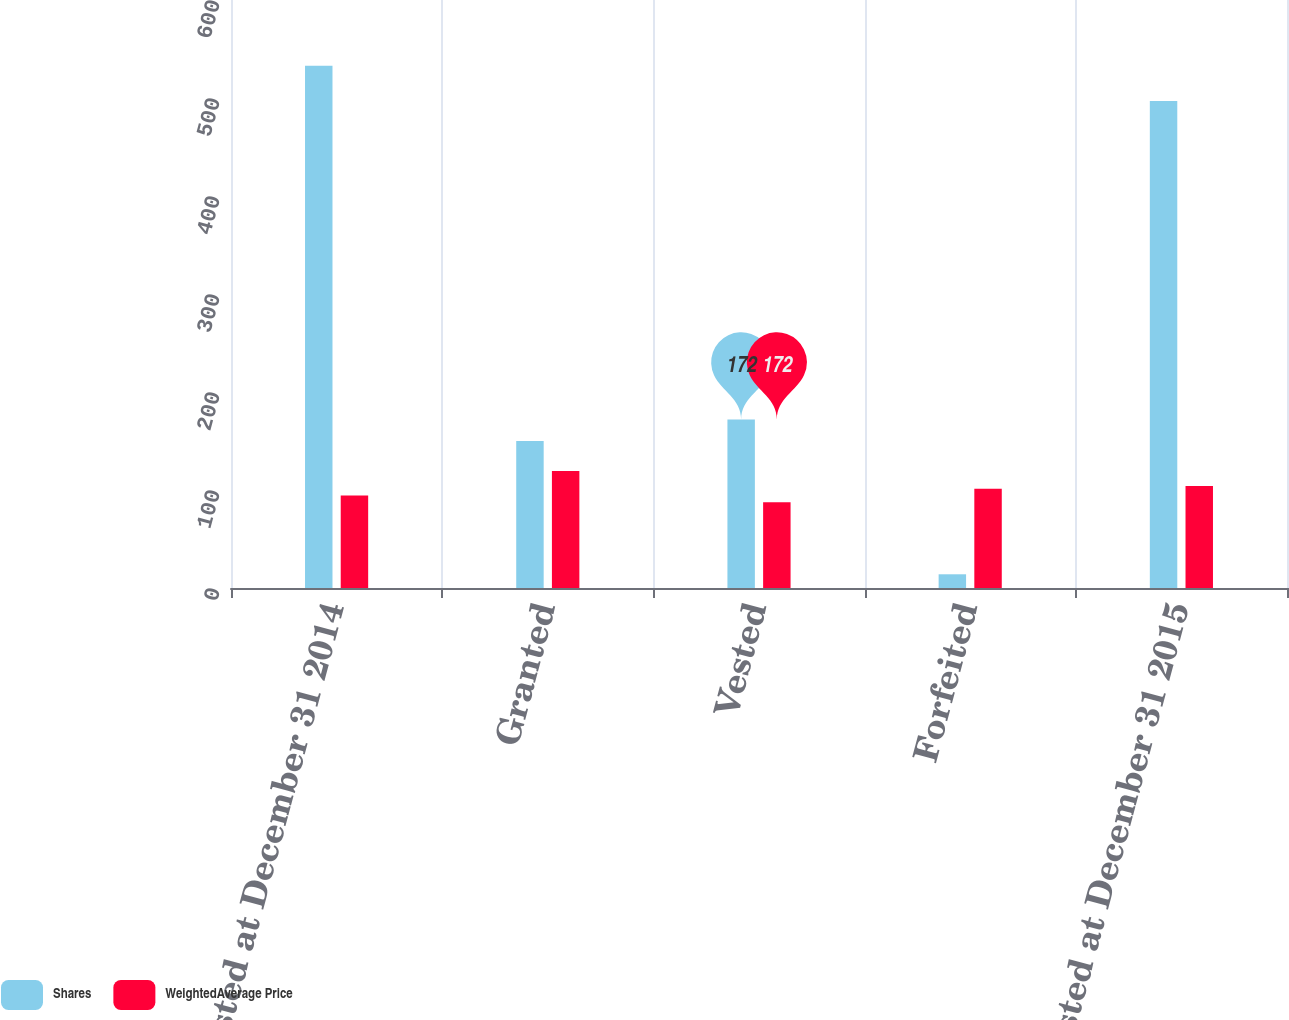Convert chart. <chart><loc_0><loc_0><loc_500><loc_500><stacked_bar_chart><ecel><fcel>Unvested at December 31 2014<fcel>Granted<fcel>Vested<fcel>Forfeited<fcel>Unvested at December 31 2015<nl><fcel>Shares<fcel>533<fcel>150<fcel>172<fcel>14<fcel>497<nl><fcel>WeightedAverage Price<fcel>94.38<fcel>119.46<fcel>87.44<fcel>101.17<fcel>104.16<nl></chart> 